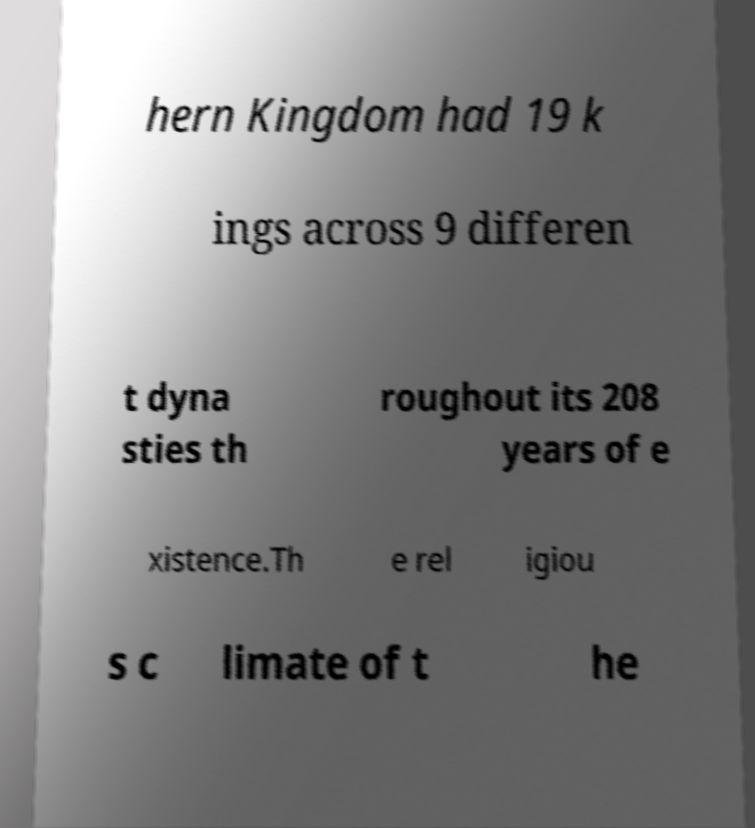Can you accurately transcribe the text from the provided image for me? hern Kingdom had 19 k ings across 9 differen t dyna sties th roughout its 208 years of e xistence.Th e rel igiou s c limate of t he 